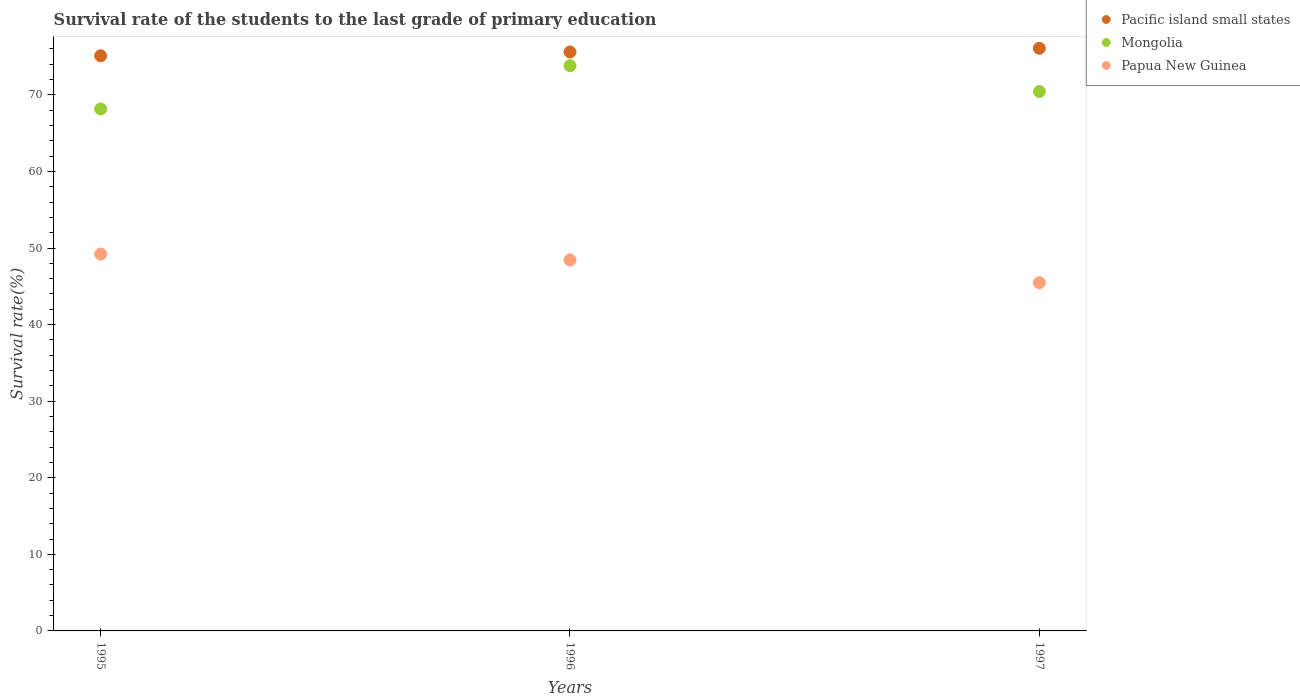What is the survival rate of the students in Mongolia in 1995?
Your answer should be compact. 68.17. Across all years, what is the maximum survival rate of the students in Pacific island small states?
Ensure brevity in your answer.  76.09. Across all years, what is the minimum survival rate of the students in Pacific island small states?
Ensure brevity in your answer.  75.11. In which year was the survival rate of the students in Papua New Guinea minimum?
Make the answer very short. 1997. What is the total survival rate of the students in Papua New Guinea in the graph?
Provide a succinct answer. 143.14. What is the difference between the survival rate of the students in Mongolia in 1995 and that in 1996?
Offer a terse response. -5.65. What is the difference between the survival rate of the students in Mongolia in 1995 and the survival rate of the students in Pacific island small states in 1996?
Provide a succinct answer. -7.44. What is the average survival rate of the students in Papua New Guinea per year?
Provide a succinct answer. 47.71. In the year 1997, what is the difference between the survival rate of the students in Pacific island small states and survival rate of the students in Mongolia?
Your answer should be compact. 5.64. What is the ratio of the survival rate of the students in Mongolia in 1995 to that in 1996?
Give a very brief answer. 0.92. Is the survival rate of the students in Mongolia in 1995 less than that in 1997?
Provide a succinct answer. Yes. Is the difference between the survival rate of the students in Pacific island small states in 1995 and 1997 greater than the difference between the survival rate of the students in Mongolia in 1995 and 1997?
Your response must be concise. Yes. What is the difference between the highest and the second highest survival rate of the students in Mongolia?
Make the answer very short. 3.37. What is the difference between the highest and the lowest survival rate of the students in Pacific island small states?
Your answer should be compact. 0.98. In how many years, is the survival rate of the students in Mongolia greater than the average survival rate of the students in Mongolia taken over all years?
Give a very brief answer. 1. Is the sum of the survival rate of the students in Pacific island small states in 1996 and 1997 greater than the maximum survival rate of the students in Mongolia across all years?
Your answer should be very brief. Yes. Is the survival rate of the students in Papua New Guinea strictly less than the survival rate of the students in Mongolia over the years?
Your response must be concise. Yes. How many years are there in the graph?
Give a very brief answer. 3. Does the graph contain any zero values?
Provide a succinct answer. No. Where does the legend appear in the graph?
Offer a very short reply. Top right. What is the title of the graph?
Offer a terse response. Survival rate of the students to the last grade of primary education. What is the label or title of the Y-axis?
Your answer should be very brief. Survival rate(%). What is the Survival rate(%) in Pacific island small states in 1995?
Give a very brief answer. 75.11. What is the Survival rate(%) of Mongolia in 1995?
Your response must be concise. 68.17. What is the Survival rate(%) in Papua New Guinea in 1995?
Offer a very short reply. 49.21. What is the Survival rate(%) of Pacific island small states in 1996?
Provide a short and direct response. 75.61. What is the Survival rate(%) of Mongolia in 1996?
Your response must be concise. 73.82. What is the Survival rate(%) in Papua New Guinea in 1996?
Offer a very short reply. 48.45. What is the Survival rate(%) in Pacific island small states in 1997?
Give a very brief answer. 76.09. What is the Survival rate(%) of Mongolia in 1997?
Your answer should be very brief. 70.45. What is the Survival rate(%) in Papua New Guinea in 1997?
Offer a very short reply. 45.48. Across all years, what is the maximum Survival rate(%) of Pacific island small states?
Keep it short and to the point. 76.09. Across all years, what is the maximum Survival rate(%) of Mongolia?
Your response must be concise. 73.82. Across all years, what is the maximum Survival rate(%) of Papua New Guinea?
Keep it short and to the point. 49.21. Across all years, what is the minimum Survival rate(%) of Pacific island small states?
Ensure brevity in your answer.  75.11. Across all years, what is the minimum Survival rate(%) in Mongolia?
Your answer should be very brief. 68.17. Across all years, what is the minimum Survival rate(%) of Papua New Guinea?
Ensure brevity in your answer.  45.48. What is the total Survival rate(%) in Pacific island small states in the graph?
Make the answer very short. 226.8. What is the total Survival rate(%) in Mongolia in the graph?
Provide a short and direct response. 212.43. What is the total Survival rate(%) of Papua New Guinea in the graph?
Give a very brief answer. 143.14. What is the difference between the Survival rate(%) of Pacific island small states in 1995 and that in 1996?
Keep it short and to the point. -0.5. What is the difference between the Survival rate(%) in Mongolia in 1995 and that in 1996?
Your response must be concise. -5.65. What is the difference between the Survival rate(%) in Papua New Guinea in 1995 and that in 1996?
Give a very brief answer. 0.77. What is the difference between the Survival rate(%) in Pacific island small states in 1995 and that in 1997?
Your response must be concise. -0.98. What is the difference between the Survival rate(%) in Mongolia in 1995 and that in 1997?
Your response must be concise. -2.28. What is the difference between the Survival rate(%) of Papua New Guinea in 1995 and that in 1997?
Offer a terse response. 3.73. What is the difference between the Survival rate(%) of Pacific island small states in 1996 and that in 1997?
Ensure brevity in your answer.  -0.48. What is the difference between the Survival rate(%) in Mongolia in 1996 and that in 1997?
Make the answer very short. 3.37. What is the difference between the Survival rate(%) in Papua New Guinea in 1996 and that in 1997?
Provide a succinct answer. 2.97. What is the difference between the Survival rate(%) of Pacific island small states in 1995 and the Survival rate(%) of Mongolia in 1996?
Ensure brevity in your answer.  1.29. What is the difference between the Survival rate(%) of Pacific island small states in 1995 and the Survival rate(%) of Papua New Guinea in 1996?
Provide a short and direct response. 26.66. What is the difference between the Survival rate(%) of Mongolia in 1995 and the Survival rate(%) of Papua New Guinea in 1996?
Offer a terse response. 19.72. What is the difference between the Survival rate(%) in Pacific island small states in 1995 and the Survival rate(%) in Mongolia in 1997?
Offer a very short reply. 4.66. What is the difference between the Survival rate(%) of Pacific island small states in 1995 and the Survival rate(%) of Papua New Guinea in 1997?
Offer a terse response. 29.63. What is the difference between the Survival rate(%) of Mongolia in 1995 and the Survival rate(%) of Papua New Guinea in 1997?
Provide a succinct answer. 22.69. What is the difference between the Survival rate(%) of Pacific island small states in 1996 and the Survival rate(%) of Mongolia in 1997?
Provide a succinct answer. 5.16. What is the difference between the Survival rate(%) of Pacific island small states in 1996 and the Survival rate(%) of Papua New Guinea in 1997?
Your answer should be very brief. 30.13. What is the difference between the Survival rate(%) of Mongolia in 1996 and the Survival rate(%) of Papua New Guinea in 1997?
Provide a short and direct response. 28.33. What is the average Survival rate(%) in Pacific island small states per year?
Make the answer very short. 75.6. What is the average Survival rate(%) in Mongolia per year?
Make the answer very short. 70.81. What is the average Survival rate(%) in Papua New Guinea per year?
Ensure brevity in your answer.  47.71. In the year 1995, what is the difference between the Survival rate(%) in Pacific island small states and Survival rate(%) in Mongolia?
Your response must be concise. 6.94. In the year 1995, what is the difference between the Survival rate(%) of Pacific island small states and Survival rate(%) of Papua New Guinea?
Keep it short and to the point. 25.89. In the year 1995, what is the difference between the Survival rate(%) in Mongolia and Survival rate(%) in Papua New Guinea?
Provide a succinct answer. 18.95. In the year 1996, what is the difference between the Survival rate(%) in Pacific island small states and Survival rate(%) in Mongolia?
Give a very brief answer. 1.79. In the year 1996, what is the difference between the Survival rate(%) of Pacific island small states and Survival rate(%) of Papua New Guinea?
Make the answer very short. 27.16. In the year 1996, what is the difference between the Survival rate(%) in Mongolia and Survival rate(%) in Papua New Guinea?
Provide a short and direct response. 25.37. In the year 1997, what is the difference between the Survival rate(%) of Pacific island small states and Survival rate(%) of Mongolia?
Make the answer very short. 5.64. In the year 1997, what is the difference between the Survival rate(%) in Pacific island small states and Survival rate(%) in Papua New Guinea?
Provide a short and direct response. 30.61. In the year 1997, what is the difference between the Survival rate(%) of Mongolia and Survival rate(%) of Papua New Guinea?
Your answer should be compact. 24.96. What is the ratio of the Survival rate(%) of Mongolia in 1995 to that in 1996?
Provide a short and direct response. 0.92. What is the ratio of the Survival rate(%) in Papua New Guinea in 1995 to that in 1996?
Provide a short and direct response. 1.02. What is the ratio of the Survival rate(%) of Pacific island small states in 1995 to that in 1997?
Provide a short and direct response. 0.99. What is the ratio of the Survival rate(%) of Papua New Guinea in 1995 to that in 1997?
Offer a terse response. 1.08. What is the ratio of the Survival rate(%) in Pacific island small states in 1996 to that in 1997?
Provide a succinct answer. 0.99. What is the ratio of the Survival rate(%) of Mongolia in 1996 to that in 1997?
Your answer should be very brief. 1.05. What is the ratio of the Survival rate(%) in Papua New Guinea in 1996 to that in 1997?
Ensure brevity in your answer.  1.07. What is the difference between the highest and the second highest Survival rate(%) of Pacific island small states?
Make the answer very short. 0.48. What is the difference between the highest and the second highest Survival rate(%) of Mongolia?
Keep it short and to the point. 3.37. What is the difference between the highest and the second highest Survival rate(%) in Papua New Guinea?
Make the answer very short. 0.77. What is the difference between the highest and the lowest Survival rate(%) of Pacific island small states?
Give a very brief answer. 0.98. What is the difference between the highest and the lowest Survival rate(%) of Mongolia?
Make the answer very short. 5.65. What is the difference between the highest and the lowest Survival rate(%) of Papua New Guinea?
Make the answer very short. 3.73. 